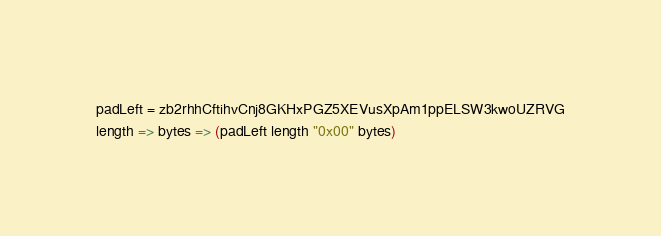Convert code to text. <code><loc_0><loc_0><loc_500><loc_500><_MoonScript_>padLeft = zb2rhhCftihvCnj8GKHxPGZ5XEVusXpAm1ppELSW3kwoUZRVG
length => bytes => (padLeft length "0x00" bytes)
</code> 